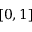<formula> <loc_0><loc_0><loc_500><loc_500>[ 0 , 1 ]</formula> 